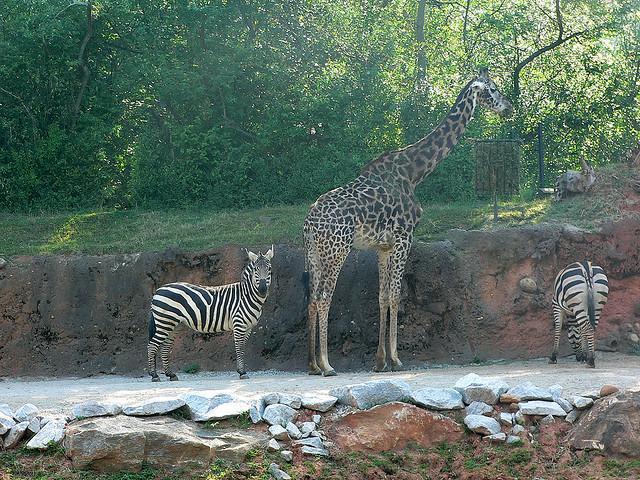How many zebras are in the picture?
Give a very brief answer. 2. How many different animals are there?
Give a very brief answer. 2. How many zebras are there?
Give a very brief answer. 2. How many people are wearing bikini?
Give a very brief answer. 0. 